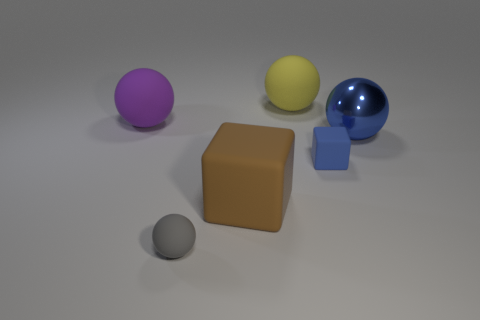Subtract all blue balls. How many balls are left? 3 Add 4 purple matte objects. How many purple matte objects exist? 5 Add 4 rubber balls. How many objects exist? 10 Subtract all gray spheres. How many spheres are left? 3 Subtract 0 red balls. How many objects are left? 6 Subtract all blocks. How many objects are left? 4 Subtract 2 balls. How many balls are left? 2 Subtract all green spheres. Subtract all purple blocks. How many spheres are left? 4 Subtract all red cubes. How many gray balls are left? 1 Subtract all tiny matte spheres. Subtract all brown rubber things. How many objects are left? 4 